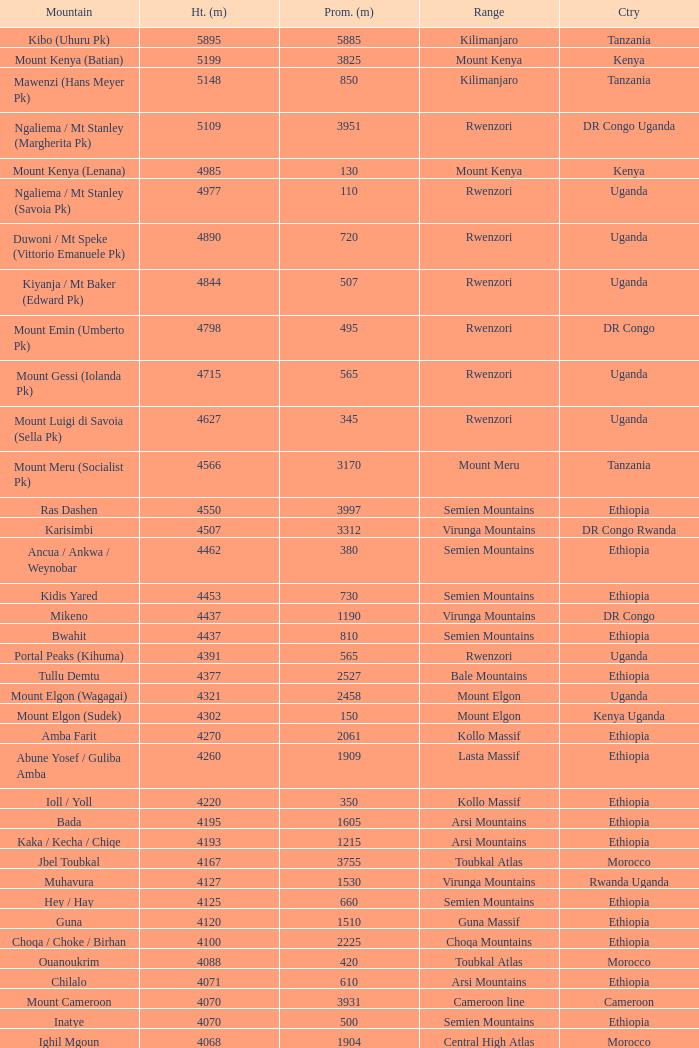Which Country has a Height (m) larger than 4100, and a Range of arsi mountains, and a Mountain of bada? Ethiopia. 